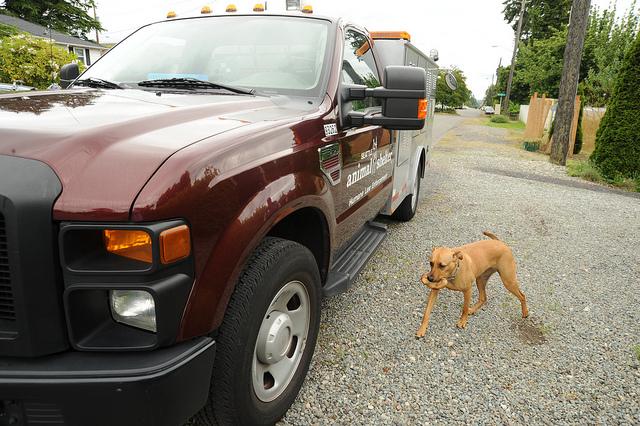What color is the dog?
Keep it brief. Brown. Is the dog sleeping?
Write a very short answer. No. Does this dog likely belong to somebody?
Concise answer only. Yes. 